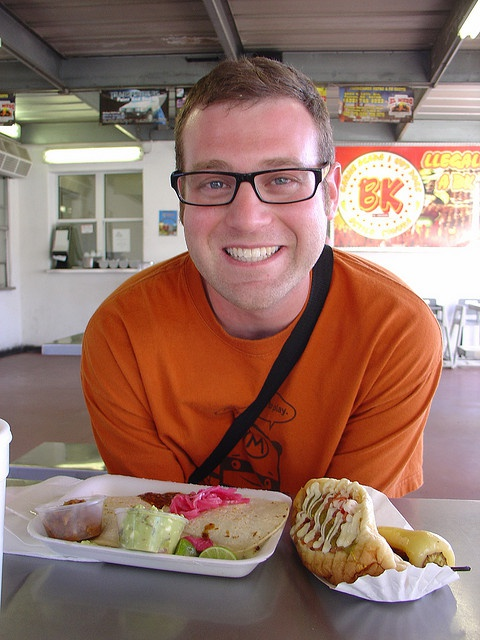Describe the objects in this image and their specific colors. I can see people in black, brown, and lightpink tones, dining table in black, gray, darkgray, and maroon tones, hot dog in black, tan, lightgray, olive, and maroon tones, and sandwich in black, tan, olive, maroon, and lightgray tones in this image. 